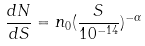Convert formula to latex. <formula><loc_0><loc_0><loc_500><loc_500>\frac { d N } { d S } = n _ { 0 } ( \frac { S } { 1 0 ^ { - 1 4 } } ) ^ { - \alpha }</formula> 